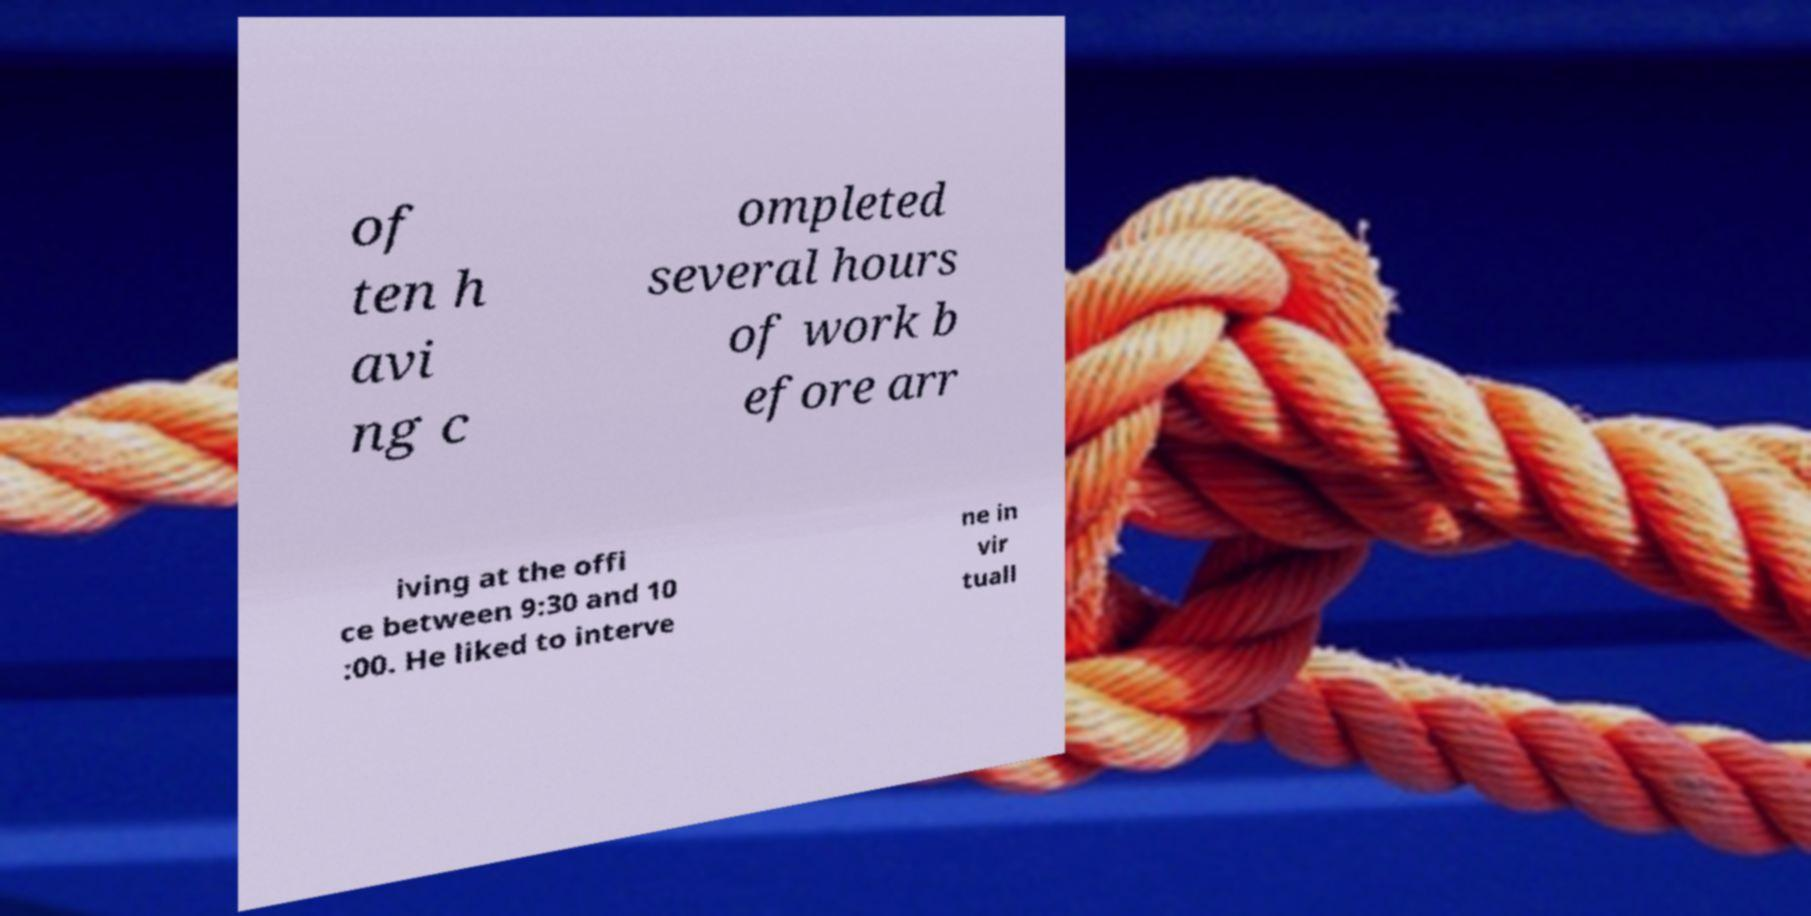Could you assist in decoding the text presented in this image and type it out clearly? of ten h avi ng c ompleted several hours of work b efore arr iving at the offi ce between 9:30 and 10 :00. He liked to interve ne in vir tuall 